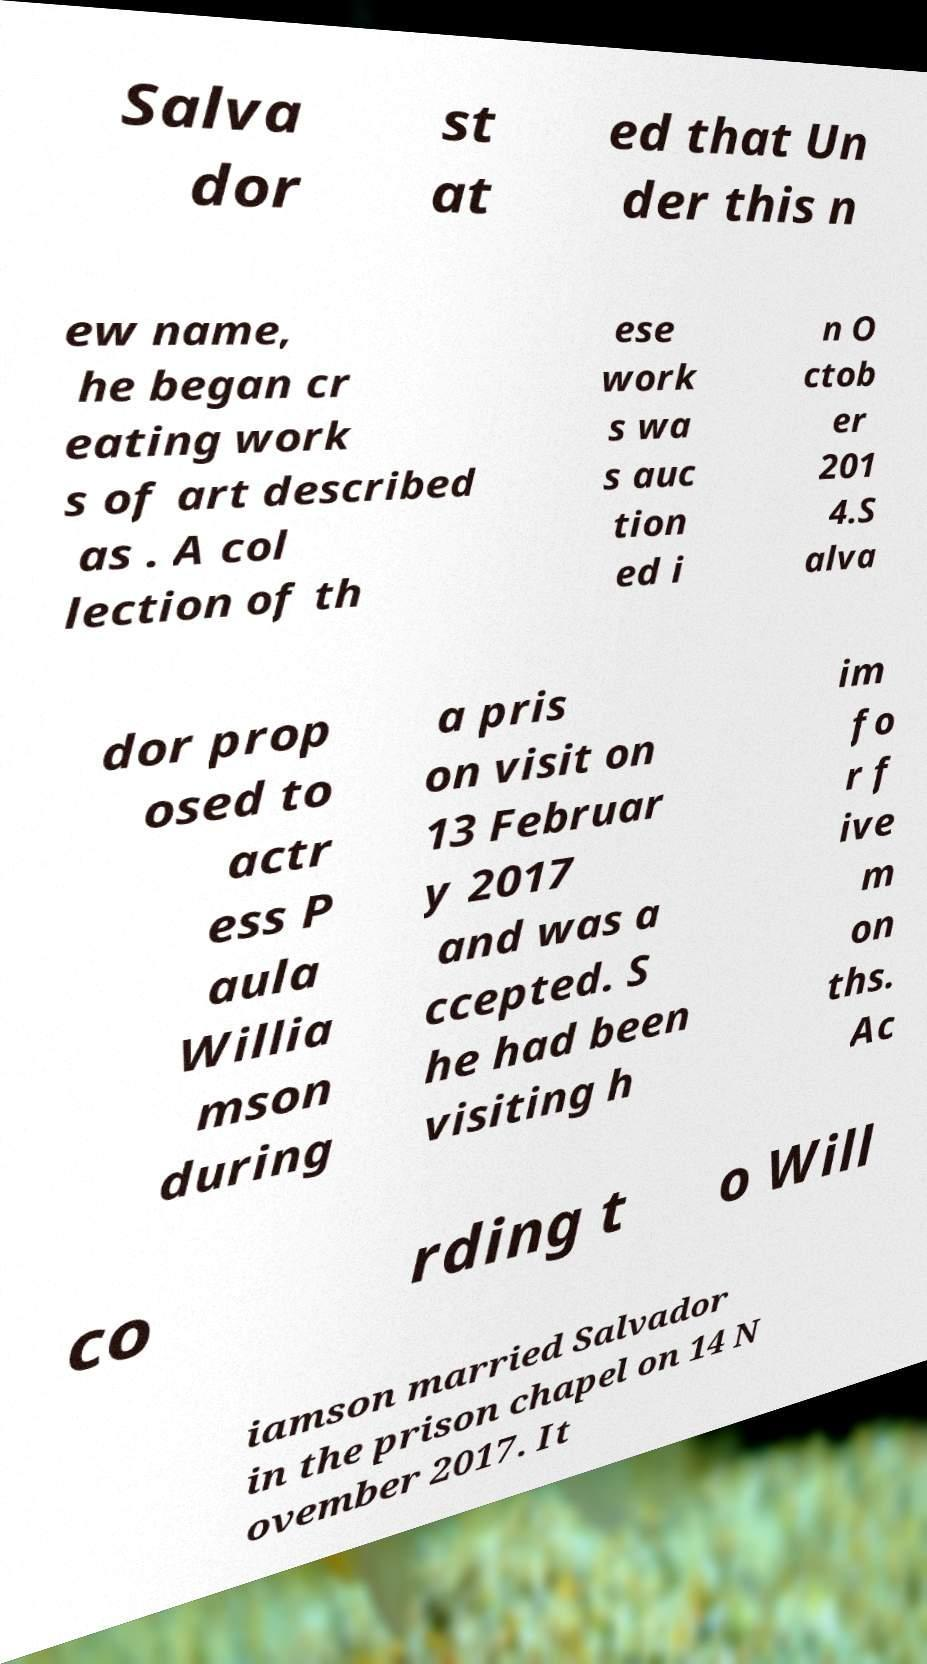Could you extract and type out the text from this image? Salva dor st at ed that Un der this n ew name, he began cr eating work s of art described as . A col lection of th ese work s wa s auc tion ed i n O ctob er 201 4.S alva dor prop osed to actr ess P aula Willia mson during a pris on visit on 13 Februar y 2017 and was a ccepted. S he had been visiting h im fo r f ive m on ths. Ac co rding t o Will iamson married Salvador in the prison chapel on 14 N ovember 2017. It 